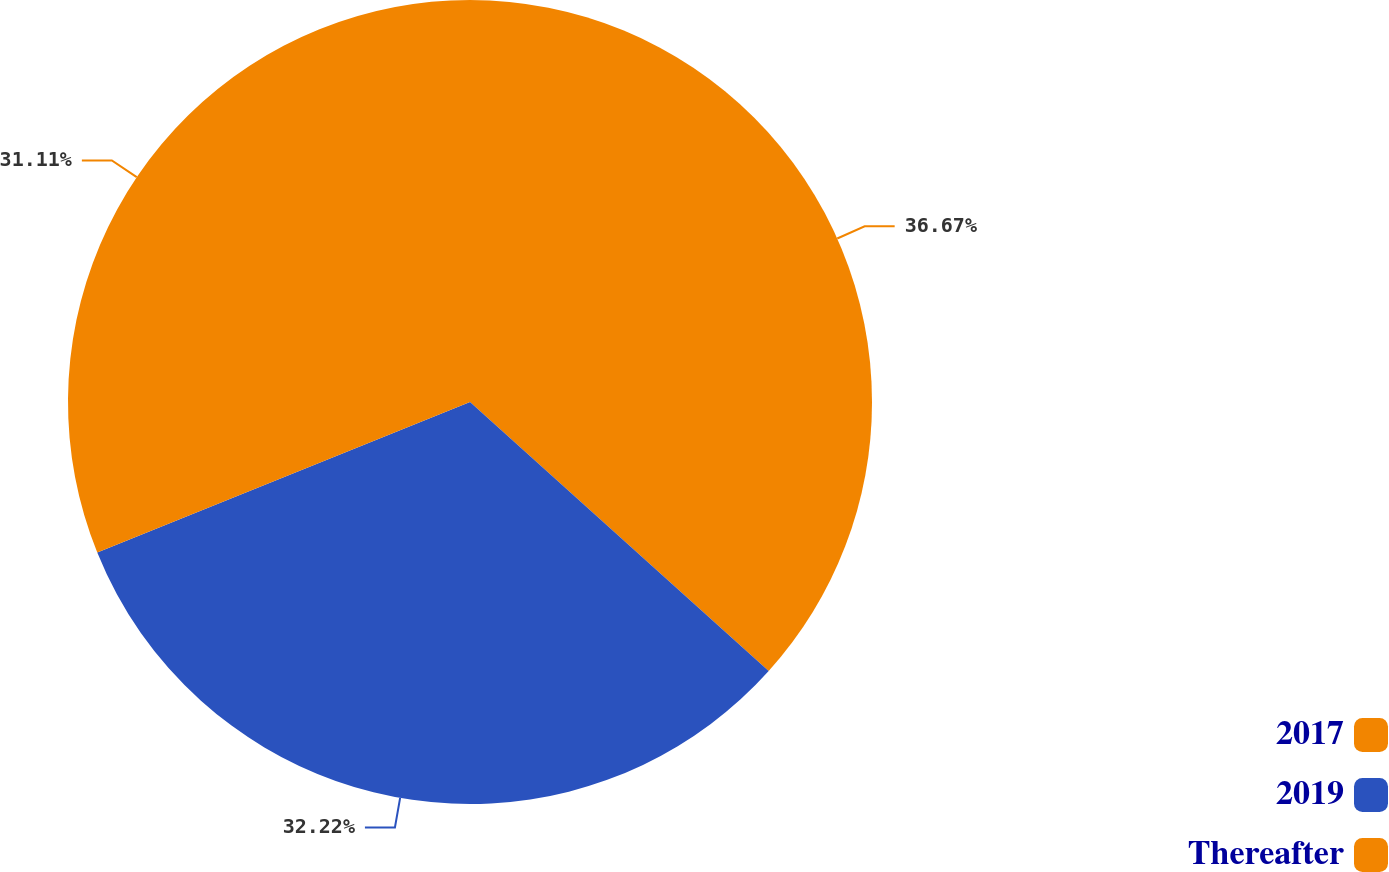Convert chart to OTSL. <chart><loc_0><loc_0><loc_500><loc_500><pie_chart><fcel>2017<fcel>2019<fcel>Thereafter<nl><fcel>36.67%<fcel>32.22%<fcel>31.11%<nl></chart> 